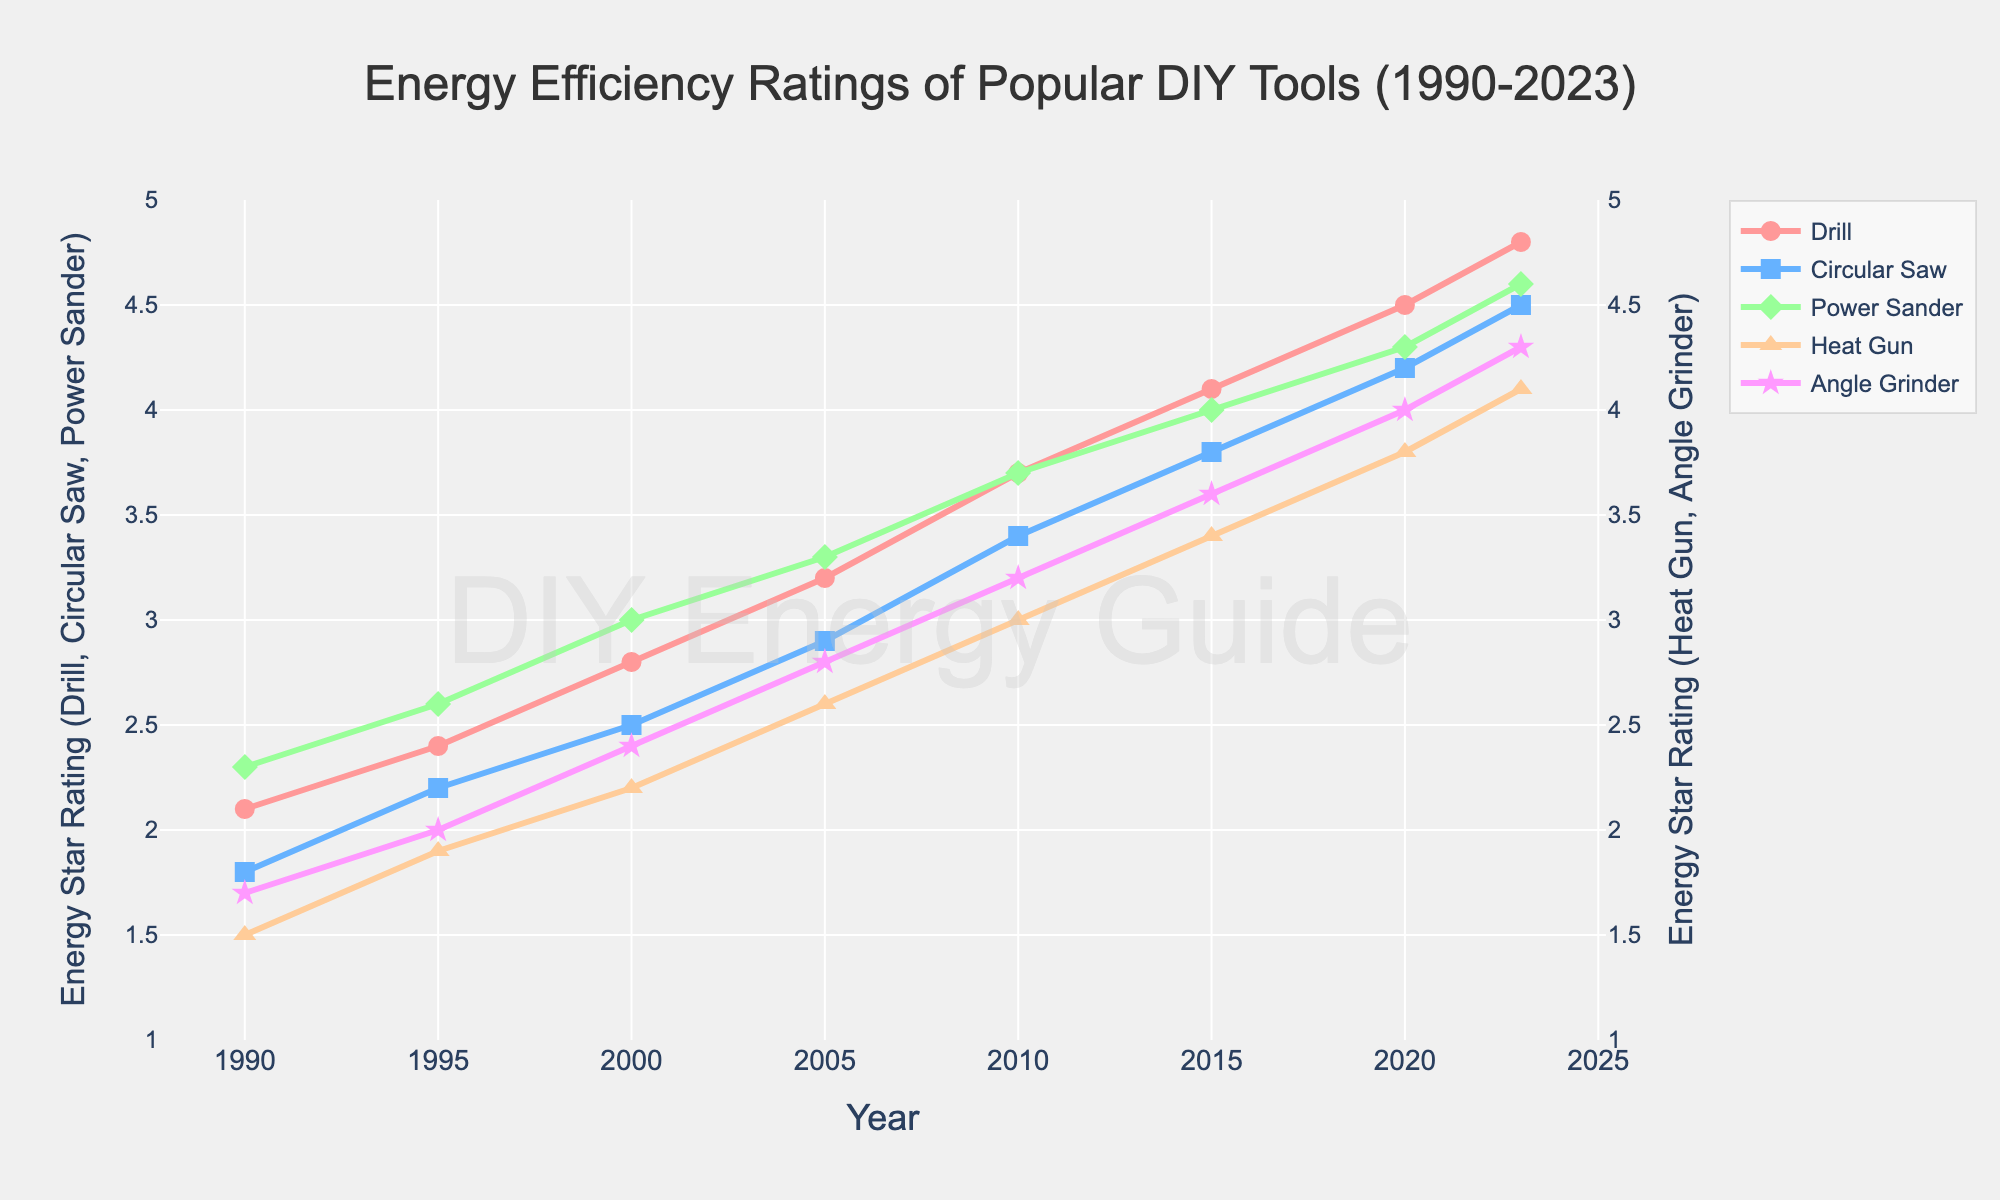what's the average energy efficiency rating of the drill in 2023 and 2020? Look at the energy efficiency ratings of the drill in 2023 (4.8) and 2020 (4.5). Calculate the average: (4.8 + 4.5) / 2 = 4.65
Answer: 4.65 Which tool had the highest increase in energy star rating from 1990 to 2023? Check the initial and final ratings for each tool. Subtract the 1990 rating from the 2023 rating: Drill: 4.8 - 2.1 = 2.7, Circular Saw: 4.5 - 1.8 = 2.7, Power Sander: 4.6 - 2.3 = 2.3, Heat Gun: 4.1 - 1.5 = 2.6, Angle Grinder: 4.3 - 1.7 = 2.6. Drill and Circular Saw had the highest increase of 2.7.
Answer: Drill and Circular Saw Which tool's energy efficiency rating improved the most between 2010 and 2015? Subtract the 2010 rating from the 2015 rating for each tool: Drill: 4.1 - 3.7 = 0.4, Circular Saw: 3.8 - 3.4 = 0.4, Power Sander: 4.0 - 3.7 = 0.3, Heat Gun: 3.4 - 3.0 = 0.4, Angle Grinder: 3.6 - 3.2 = 0.4. Several tools improved by 0.4, so Drill, Circular Saw, Heat Gun, and Angle Grinder improved the most.
Answer: Drill, Circular Saw, Heat Gun, and Angle Grinder Which tool has the highest energy star rating in 2023? Compare the energy efficiency ratings of all tools in 2023. The ratings are Drill: 4.8, Circular Saw: 4.5, Power Sander: 4.6, Heat Gun: 4.1, Angle Grinder: 4.3. The Drill has the highest rating at 4.8.
Answer: Drill Between 2000 and 2005, which tool had the smallest increase in its energy star rating? Subtract the 2000 rating from the 2005 rating for each tool: Drill: 3.2 - 2.8 = 0.4, Circular Saw: 2.9 - 2.5 = 0.4, Power Sander: 3.3 - 3.0 = 0.3, Heat Gun: 2.6 - 2.2 = 0.4, Angle Grinder: 2.8 - 2.4 = 0.4. The Power Sander had the smallest increase of 0.3.
Answer: Power Sander By how many points did the Heat Gun's energy efficiency rating improve from 1995 to 2023? Subtract the 1995 rating (1.9) from the 2023 rating (4.1) for the Heat Gun: 4.1 - 1.9 = 2.2 points.
Answer: 2.2 What is the difference between the highest and the lowest energy star rating in 2000? Identify the highest (3.0 for Power Sander) and the lowest (2.2 for Heat Gun) ratings in 2000. Subtract the lowest from the highest: 3.0 - 2.2 = 0.8.
Answer: 0.8 Have any tools achieved consistent increases in energy star ratings every time interval displayed? Observe the energy star ratings of each tool over the years. The Drill and Circular Saw consistently increased their ratings from 1990 to 2023.
Answer: Drill and Circular Saw Which tool was rated the lowest in energy efficiency in 2010? Check the ratings for each tool in 2010: Drill: 3.7, Circular Saw: 3.4, Power Sander: 3.7, Heat Gun: 3.0, Angle Grinder: 3.2. The tool with the lowest rating is the Heat Gun at 3.0.
Answer: Heat Gun 